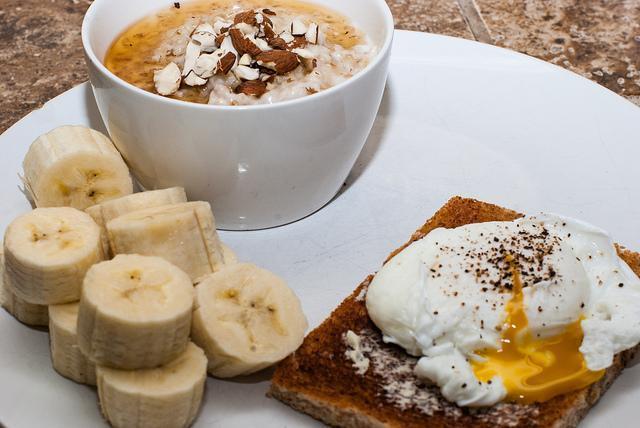How many bananas are visible?
Give a very brief answer. 5. How many elephants are there?
Give a very brief answer. 0. 